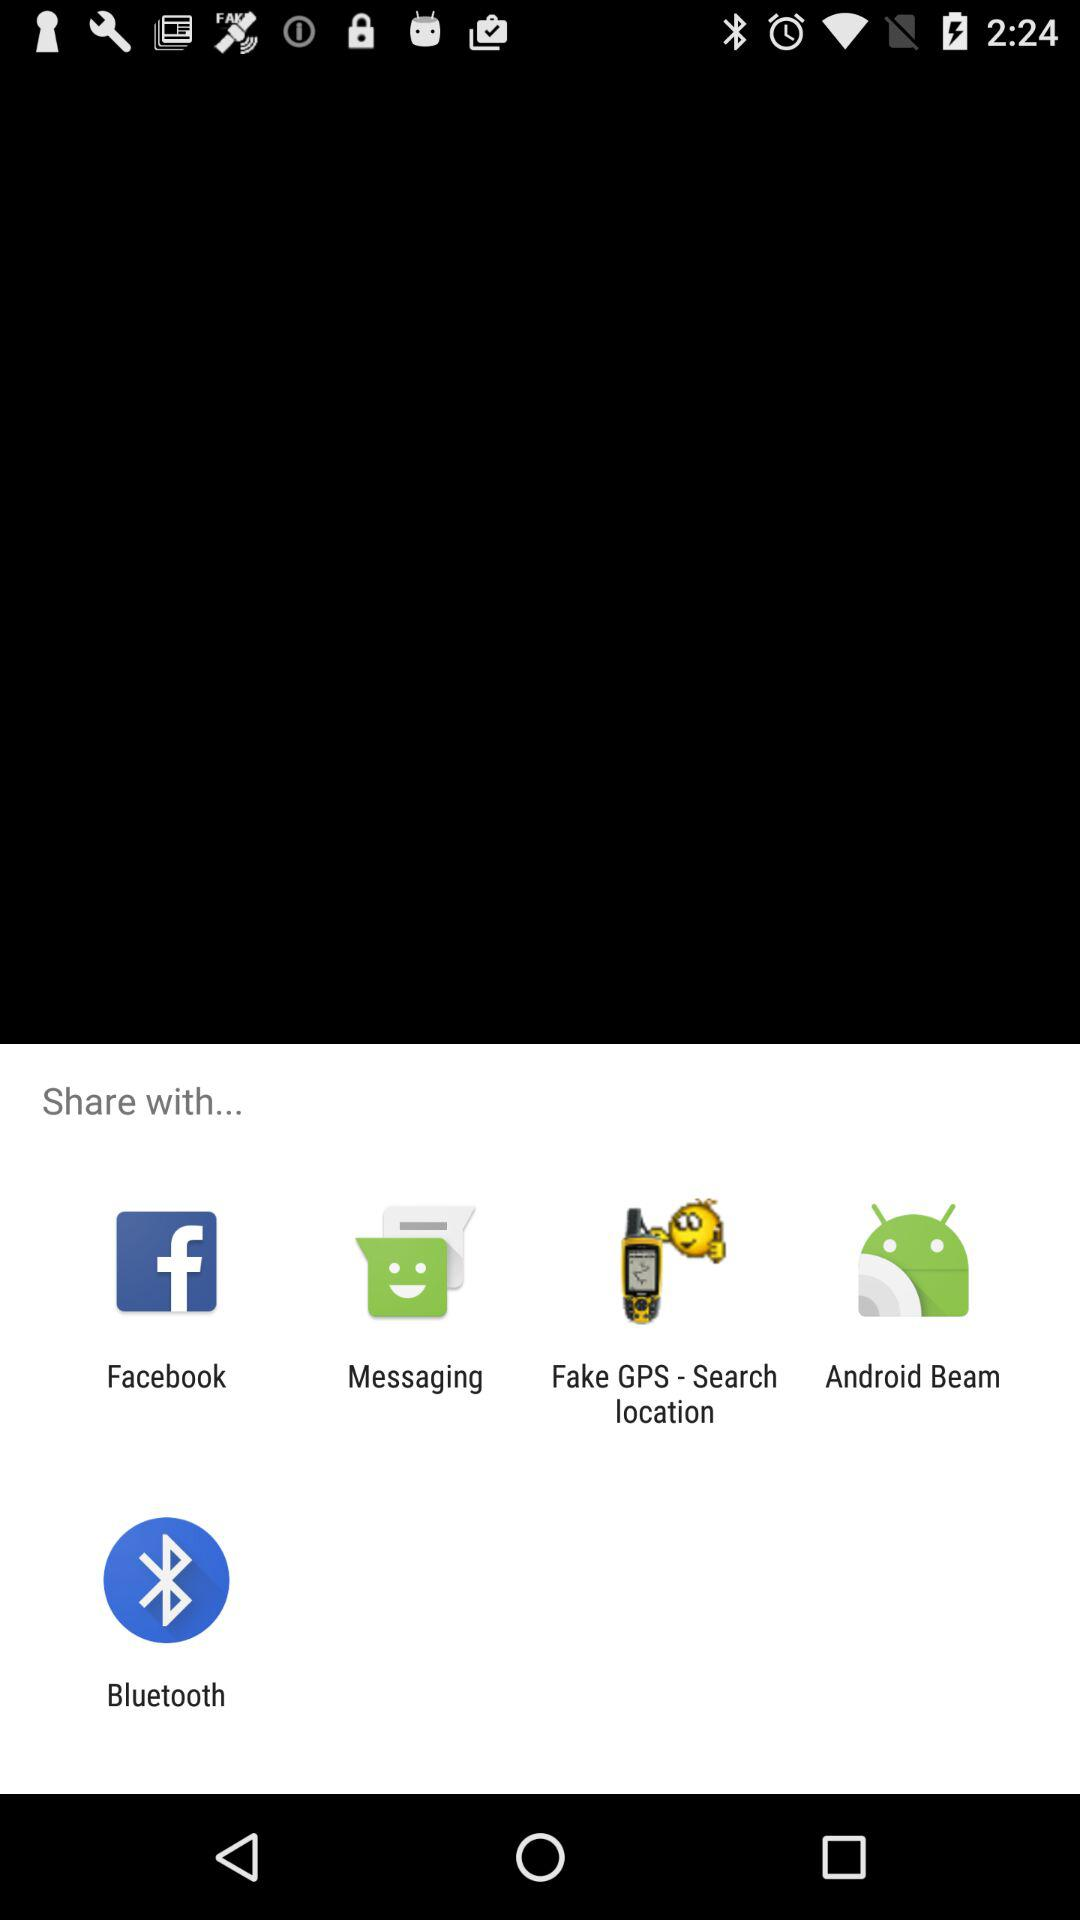Which application can be chosen to share the content? The applications "Facebook", "Messaging", "Fake GPS - Search location", "Android Beam" and "Bluetooth" can be chosen to share the content. 